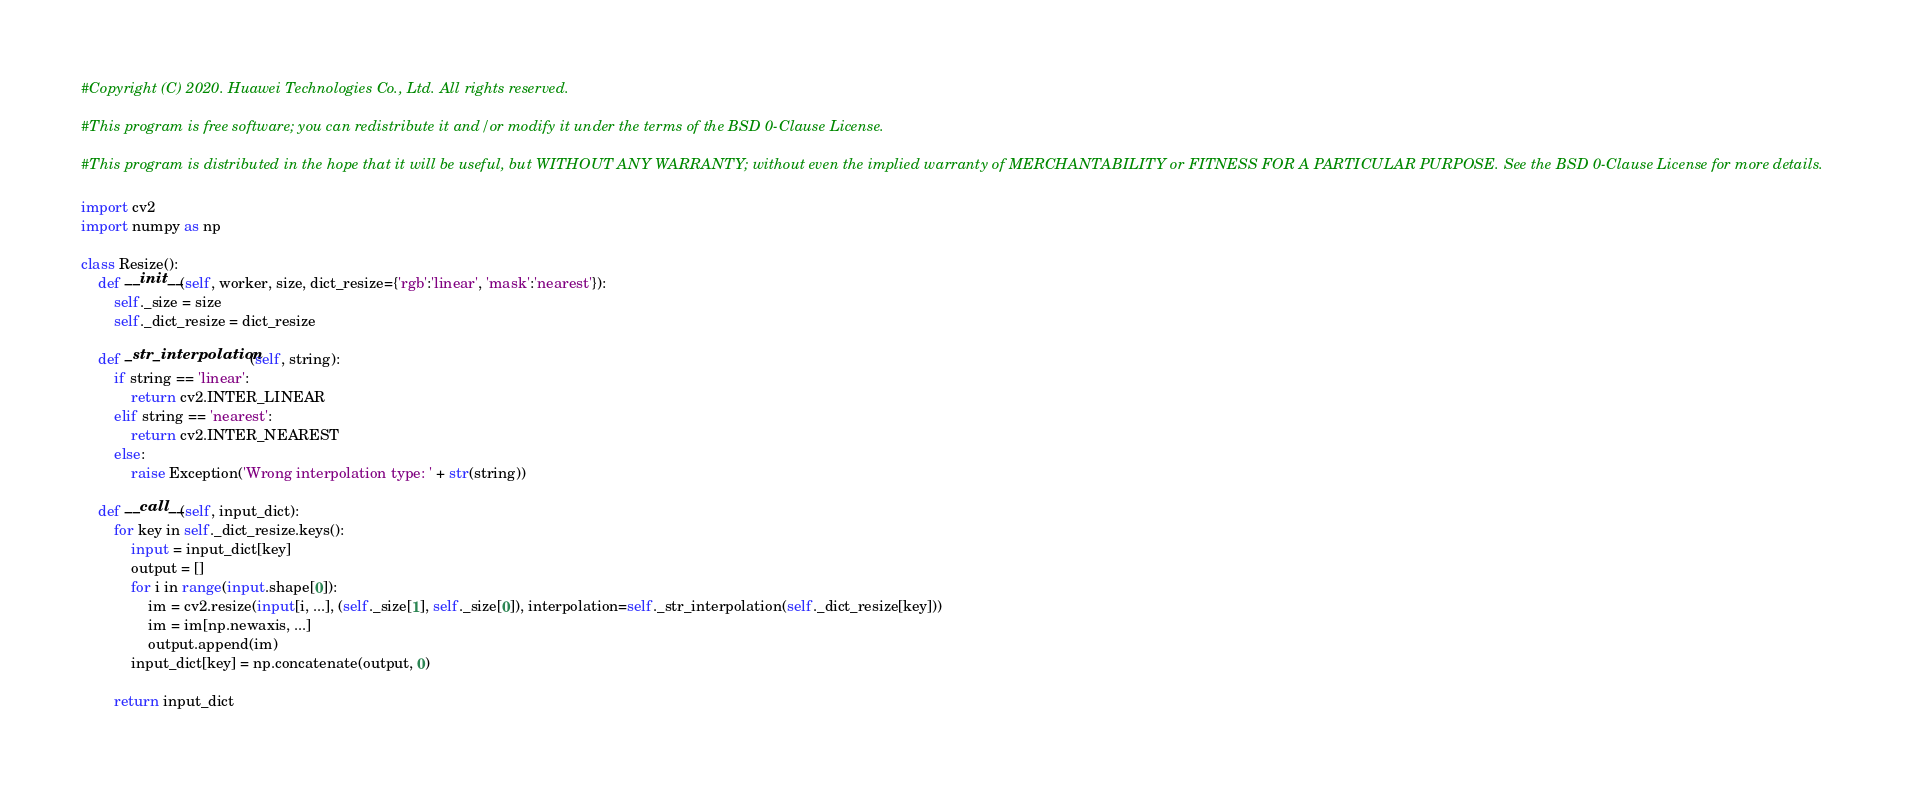<code> <loc_0><loc_0><loc_500><loc_500><_Python_>#Copyright (C) 2020. Huawei Technologies Co., Ltd. All rights reserved.

#This program is free software; you can redistribute it and/or modify it under the terms of the BSD 0-Clause License.

#This program is distributed in the hope that it will be useful, but WITHOUT ANY WARRANTY; without even the implied warranty of MERCHANTABILITY or FITNESS FOR A PARTICULAR PURPOSE. See the BSD 0-Clause License for more details.

import cv2
import numpy as np

class Resize():
    def __init__(self, worker, size, dict_resize={'rgb':'linear', 'mask':'nearest'}):
        self._size = size
        self._dict_resize = dict_resize

    def _str_interpolation(self, string):
        if string == 'linear':
            return cv2.INTER_LINEAR
        elif string == 'nearest':
            return cv2.INTER_NEAREST
        else:
            raise Exception('Wrong interpolation type: ' + str(string))

    def __call__(self, input_dict):
        for key in self._dict_resize.keys():
            input = input_dict[key]
            output = []
            for i in range(input.shape[0]):
                im = cv2.resize(input[i, ...], (self._size[1], self._size[0]), interpolation=self._str_interpolation(self._dict_resize[key]))
                im = im[np.newaxis, ...]
                output.append(im)
            input_dict[key] = np.concatenate(output, 0)

        return input_dict
</code> 